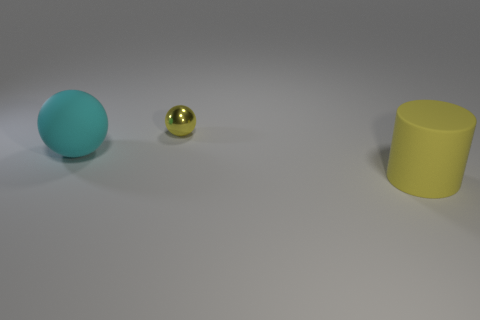Are there any other things that are the same shape as the large yellow object?
Offer a very short reply. No. Is the number of balls that are in front of the shiny thing greater than the number of big cyan metallic balls?
Give a very brief answer. Yes. What number of other objects are the same color as the large sphere?
Offer a terse response. 0. There is a rubber object left of the yellow ball; is it the same size as the metal ball?
Offer a very short reply. No. Is there a cyan thing that has the same size as the yellow matte cylinder?
Your response must be concise. Yes. There is a matte ball in front of the tiny ball; what is its color?
Keep it short and to the point. Cyan. There is a object that is both in front of the yellow shiny ball and behind the yellow rubber cylinder; what is its shape?
Make the answer very short. Sphere. How many shiny things are the same shape as the large cyan matte thing?
Make the answer very short. 1. What number of yellow cylinders are there?
Your answer should be compact. 1. How big is the thing that is both right of the cyan thing and behind the yellow matte cylinder?
Provide a succinct answer. Small. 